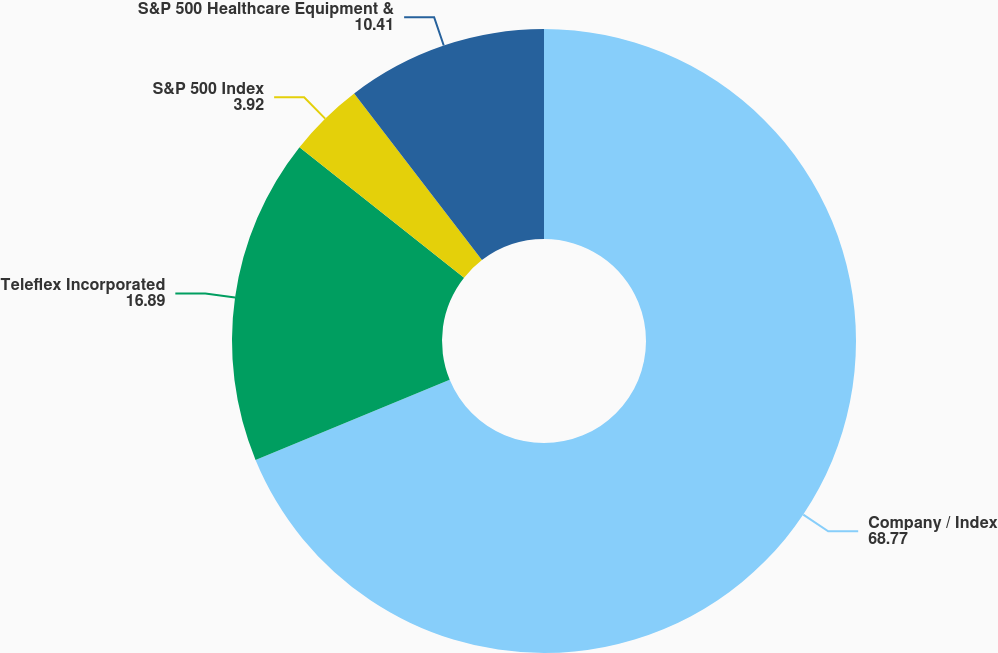Convert chart. <chart><loc_0><loc_0><loc_500><loc_500><pie_chart><fcel>Company / Index<fcel>Teleflex Incorporated<fcel>S&P 500 Index<fcel>S&P 500 Healthcare Equipment &<nl><fcel>68.77%<fcel>16.89%<fcel>3.92%<fcel>10.41%<nl></chart> 